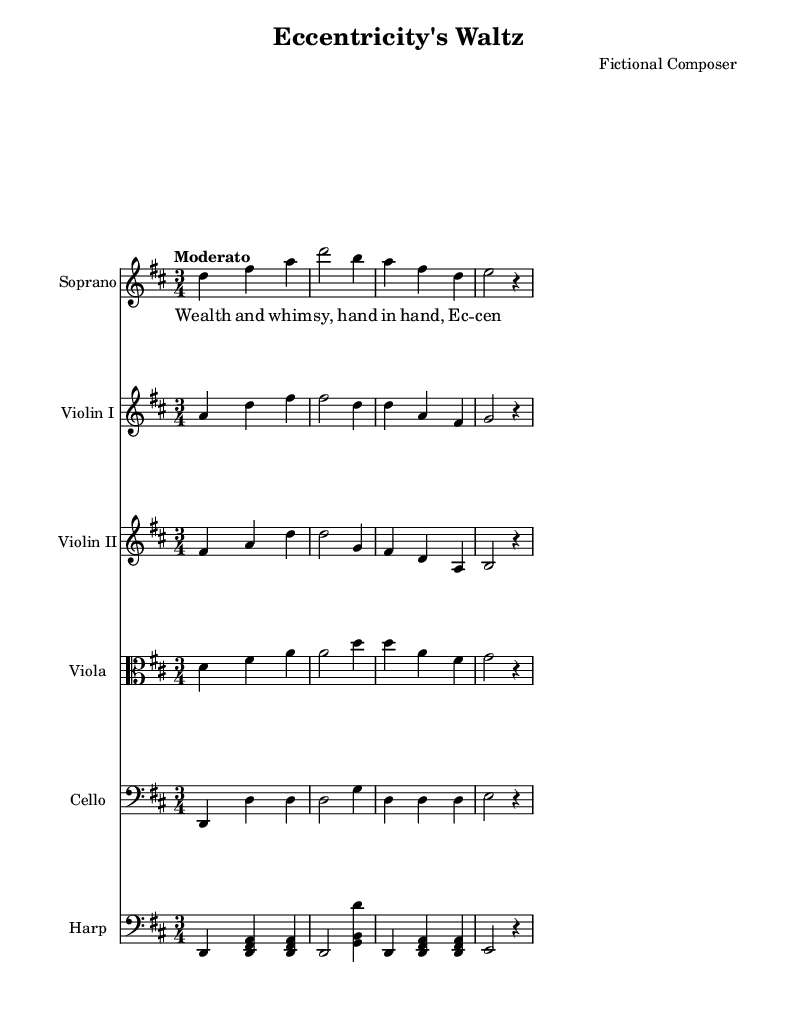What is the key signature of this music? The key signature is D major, which has two sharps: F# and C#. We can determine this by looking at the beginning of the staff where the key signature is indicated.
Answer: D major What is the time signature of this music? The time signature is 3/4, which is indicated after the key signature at the beginning of the staff. This tells us there are three beats per measure, with each beat being a quarter note.
Answer: 3/4 What is the tempo marking? The tempo marking is "Moderato," which suggests a moderate speed in the performance of the piece. Tempo markings are usually placed above the staff.
Answer: Moderato How many measures are in the soprano part? The soprano part contains four measures, which can be counted by looking at the vertical lines that divide the measures on the staff.
Answer: Four What is the lyrical theme of the text in this piece? The lyrical theme reflects on wealth and eccentricity, as indicated by the lyrics "Wealth and whim -- sy, hand in hand, Ec -- cen -- tri -- ci -- ty's de -- mand." This theme captures the essence of the opera's character motivations and emotional expression.
Answer: Wealth and eccentricity Which instruments are present in this score? The score features Soprano, Violin I, Violin II, Viola, Cello, and Harp. These instruments are indicated by their respective staff names written at the beginning of each staff.
Answer: Soprano, Violin I, Violin II, Viola, Cello, Harp What type of operatic form does this piece represent? This piece likely represents a lyrical aria, which is characterized by expressive melodies that convey the emotions of a character. In operas, arias are often used for solo voices to enhance drama and convey personal feelings.
Answer: Lyrical aria 